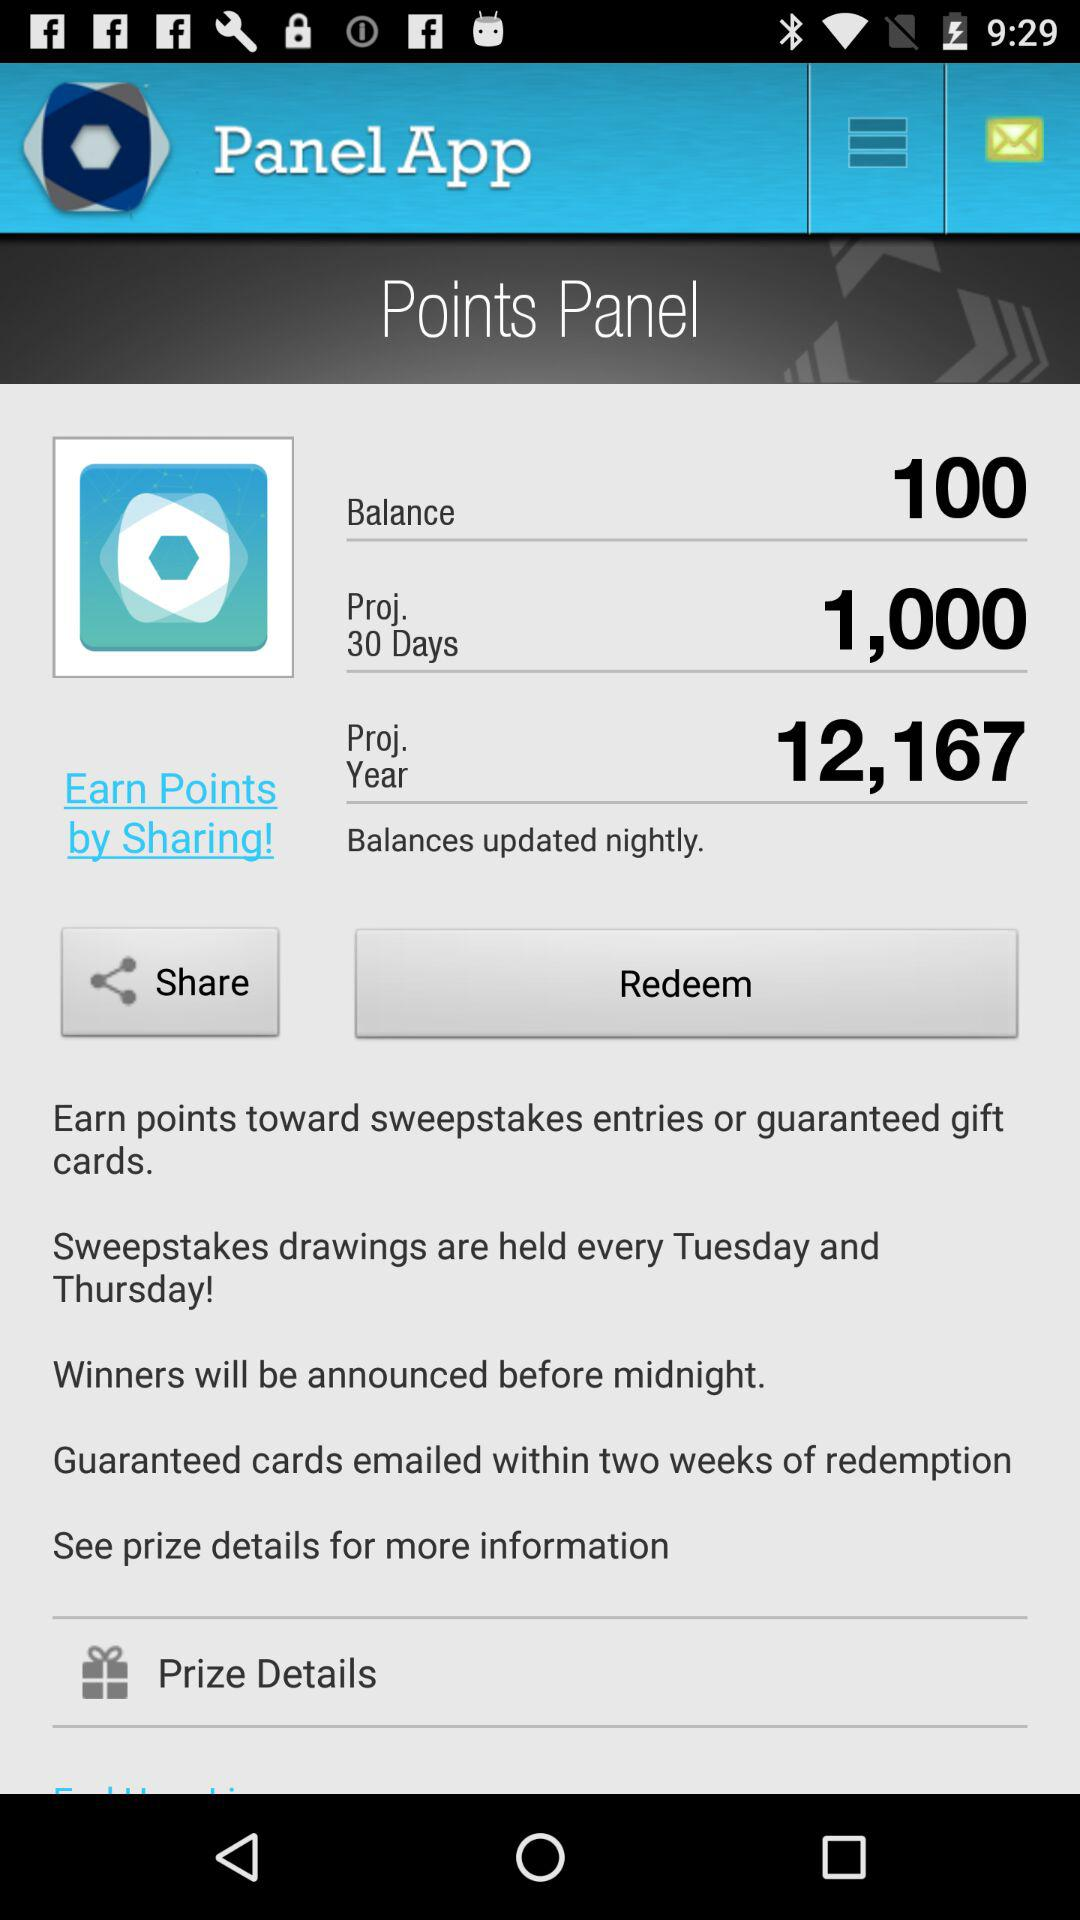How many points are projected to be earned in 30 days?
Answer the question using a single word or phrase. 1,000 